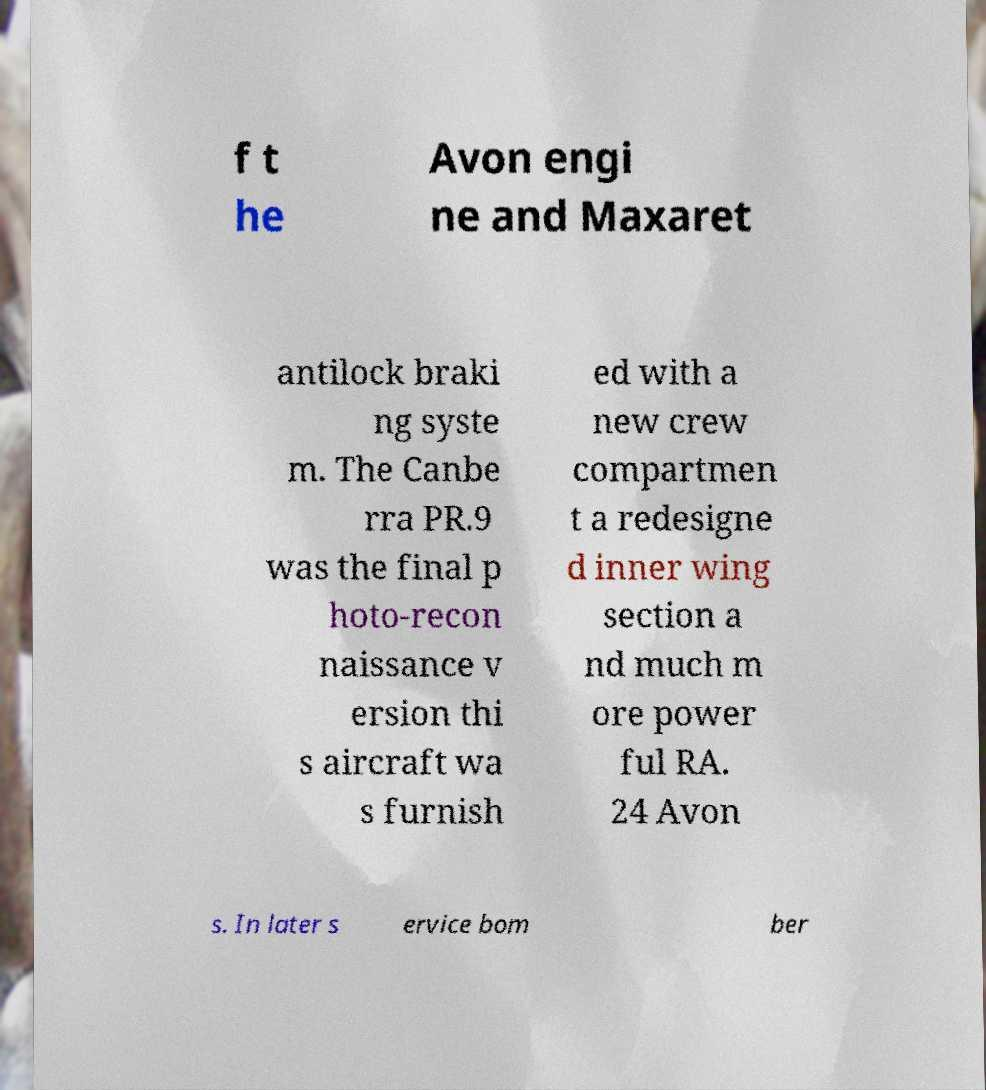Please read and relay the text visible in this image. What does it say? f t he Avon engi ne and Maxaret antilock braki ng syste m. The Canbe rra PR.9 was the final p hoto-recon naissance v ersion thi s aircraft wa s furnish ed with a new crew compartmen t a redesigne d inner wing section a nd much m ore power ful RA. 24 Avon s. In later s ervice bom ber 